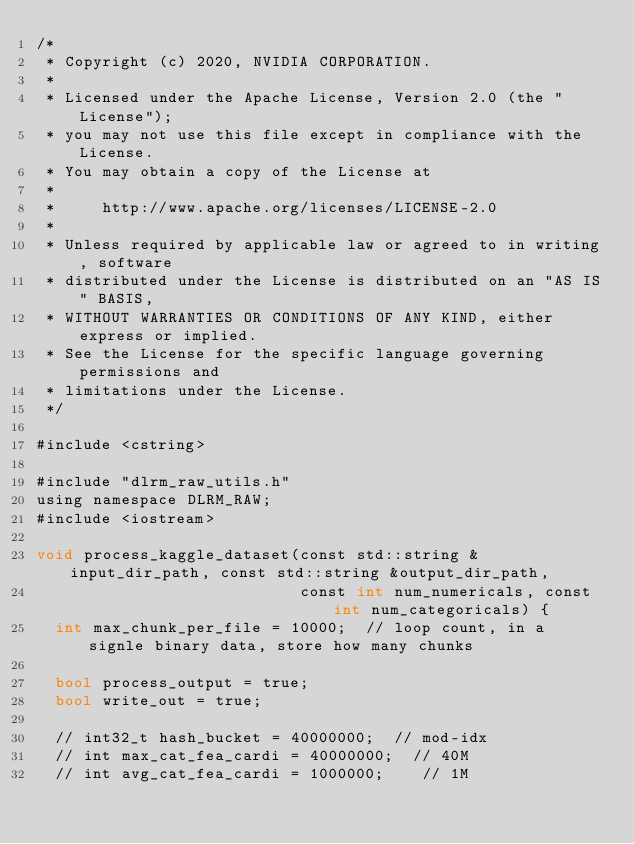Convert code to text. <code><loc_0><loc_0><loc_500><loc_500><_Cuda_>/*
 * Copyright (c) 2020, NVIDIA CORPORATION.
 *
 * Licensed under the Apache License, Version 2.0 (the "License");
 * you may not use this file except in compliance with the License.
 * You may obtain a copy of the License at
 *
 *     http://www.apache.org/licenses/LICENSE-2.0
 *
 * Unless required by applicable law or agreed to in writing, software
 * distributed under the License is distributed on an "AS IS" BASIS,
 * WITHOUT WARRANTIES OR CONDITIONS OF ANY KIND, either express or implied.
 * See the License for the specific language governing permissions and
 * limitations under the License.
 */

#include <cstring>

#include "dlrm_raw_utils.h"
using namespace DLRM_RAW;
#include <iostream>

void process_kaggle_dataset(const std::string &input_dir_path, const std::string &output_dir_path,
                            const int num_numericals, const int num_categoricals) {
  int max_chunk_per_file = 10000;  // loop count, in a signle binary data, store how many chunks

  bool process_output = true;
  bool write_out = true;

  // int32_t hash_bucket = 40000000;  // mod-idx
  // int max_cat_fea_cardi = 40000000;  // 40M
  // int avg_cat_fea_cardi = 1000000;    // 1M</code> 